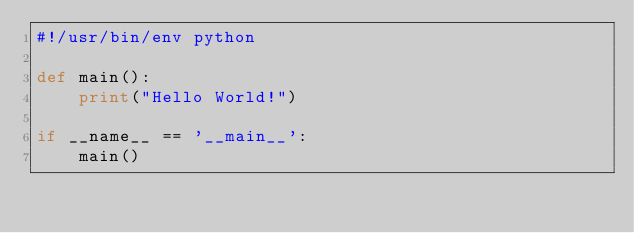<code> <loc_0><loc_0><loc_500><loc_500><_Python_>#!/usr/bin/env python

def main():
    print("Hello World!")

if __name__ == '__main__':
    main()
</code> 